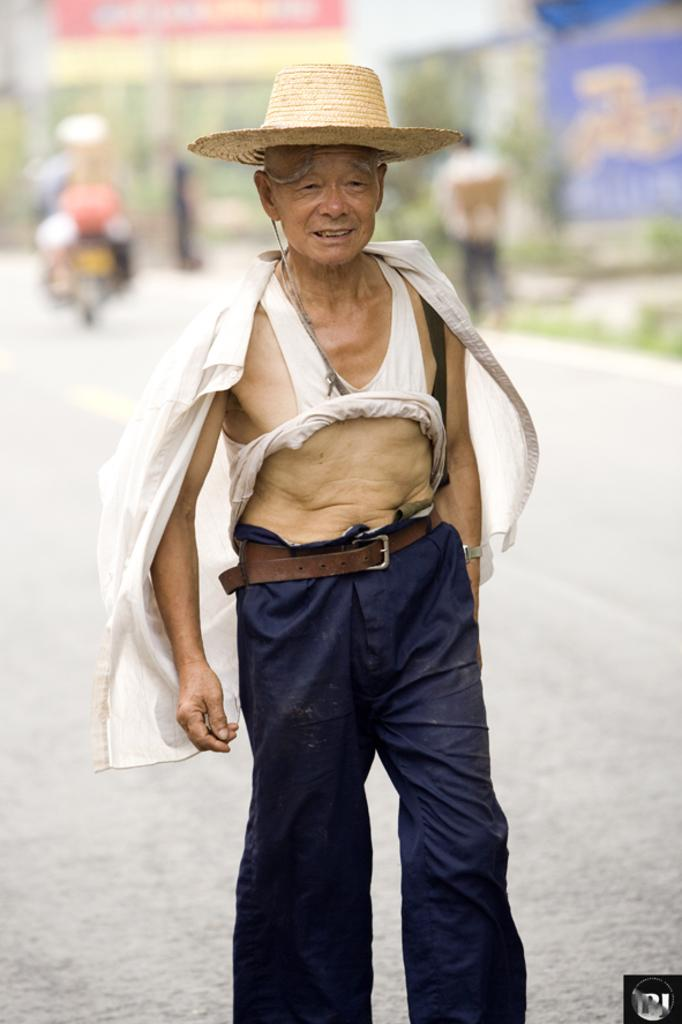Who is the main subject in the image? There is an old man in the image. What is the old man doing in the image? The old man is standing and smiling. What is the old man wearing in the image? The old man is wearing a hat. What can be seen in the background of the image? The background of the image has a blurred view. What else is present in the image besides the old man? There is a vehicle on the road and a person walking in the image. What type of beetle can be seen crawling on the old man's hat in the image? There is no beetle present on the old man's hat in the image. What attraction is the old man visiting in the image? The image does not provide information about the old man visiting any specific attraction. 